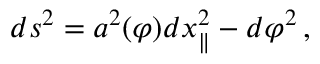<formula> <loc_0><loc_0><loc_500><loc_500>d s ^ { 2 } = a ^ { 2 } ( \varphi ) d x _ { \| } ^ { 2 } - d \varphi ^ { 2 } \, ,</formula> 